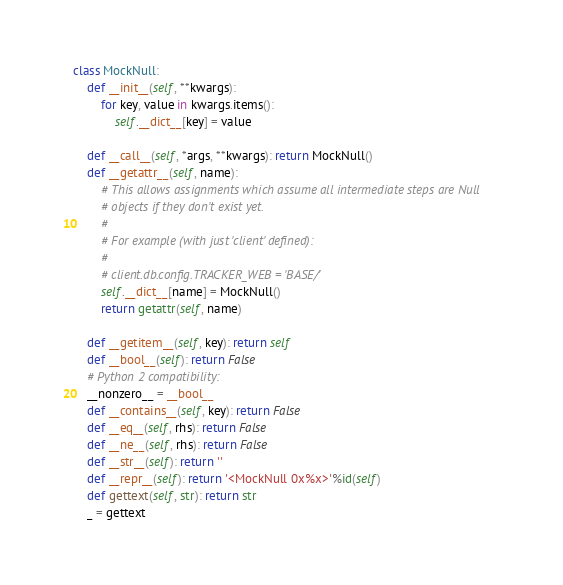<code> <loc_0><loc_0><loc_500><loc_500><_Python_>
class MockNull:
    def __init__(self, **kwargs):
        for key, value in kwargs.items():
            self.__dict__[key] = value

    def __call__(self, *args, **kwargs): return MockNull()
    def __getattr__(self, name):
        # This allows assignments which assume all intermediate steps are Null
        # objects if they don't exist yet.
        #
        # For example (with just 'client' defined):
        #
        # client.db.config.TRACKER_WEB = 'BASE/'
        self.__dict__[name] = MockNull()
        return getattr(self, name)

    def __getitem__(self, key): return self
    def __bool__(self): return False
    # Python 2 compatibility:
    __nonzero__ = __bool__
    def __contains__(self, key): return False
    def __eq__(self, rhs): return False
    def __ne__(self, rhs): return False
    def __str__(self): return ''
    def __repr__(self): return '<MockNull 0x%x>'%id(self)
    def gettext(self, str): return str
    _ = gettext
</code> 